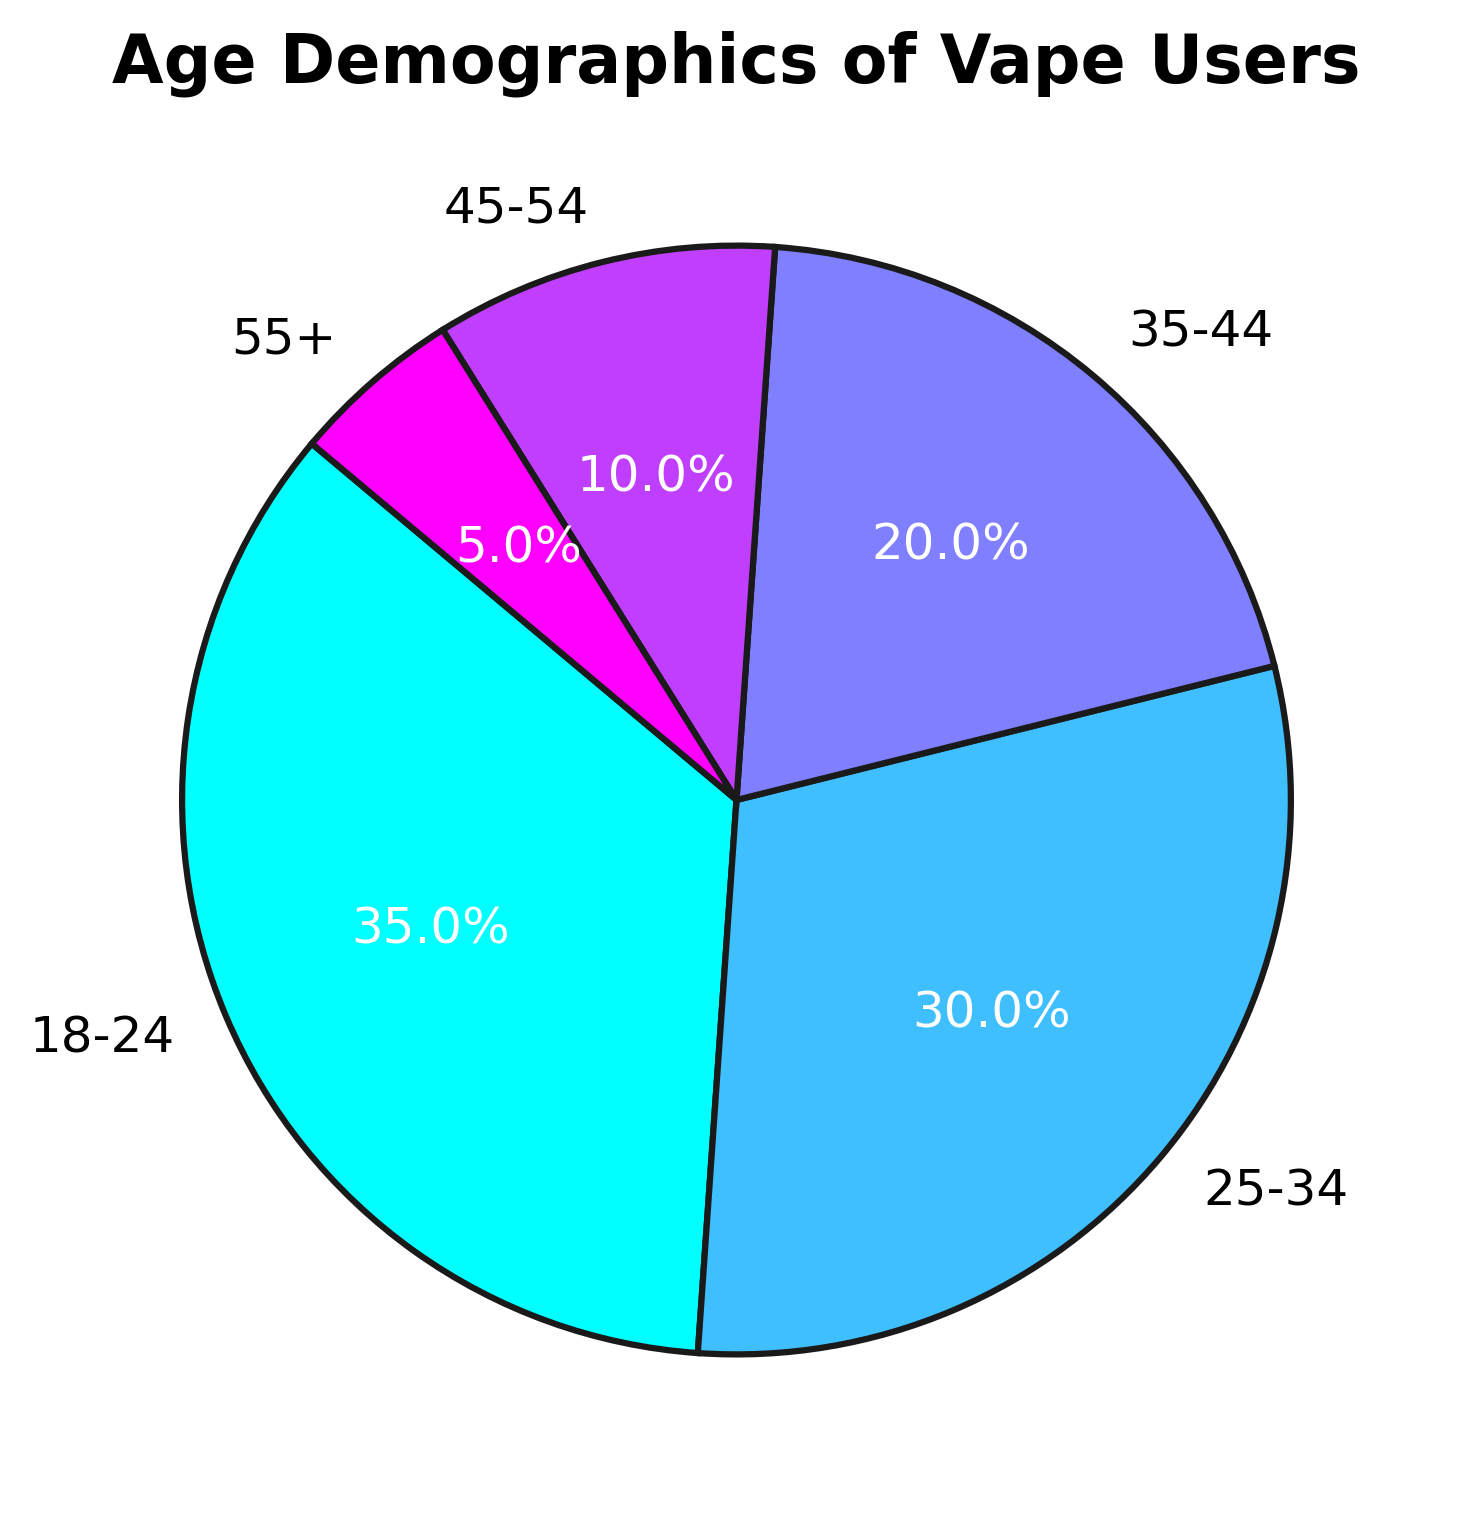What's the largest age group of vape users? The largest segment on the pie chart represents the age range from 18-24, which occupies 35% of the total.
Answer: 18-24 Which age group has the smallest percentage of vape users? The smallest segment on the pie chart is represented by the 55+ age range, which occupies only 5% of the total.
Answer: 55+ How much larger is the 18-24 age group compared to the 55+ age group? The 18-24 age group is 35% of the total, and the 55+ age group is 5%. The difference is 35 - 5 = 30%.
Answer: 30% What is the combined percentage of vape users in the 35-54 age range? Summing up the percentages of the 35-44 and 45-54 age groups gives 20% + 10% = 30%.
Answer: 30% Which age group is just below the 25-34 group in terms of percentage? The 25-34 age group has 30%. The next largest group is the 35-44 age group with 20%.
Answer: 35-44 What color is used to represent the 25-34 age group? The pie chart uses varying colors. The 25-34 age group is represented with the second color from the colormap.
Answer: [Explanation might differ without exact color, usually a description like "light purple" or "second color from the left"] How much greater is the percentage of the combined 18-34 age groups compared to the 45+ age groups? The combined percentage for 18-24 and 25-34 is 35% + 30% = 65%. For 45-54 and 55+, it is 10% + 5% = 15%. The difference is 65% - 15% = 50%.
Answer: 50% When combining the two smallest age groups, what is their total percentage? The smallest age groups are 45-54 and 55+. Adding their percentages, we get 10% + 5% = 15%.
Answer: 15% What fraction of vape users are 34 years old or younger? The age groups 18-24 and 25-34 contribute to this fraction. Together, they sum to 35% + 30% = 65%.
Answer: 65% 